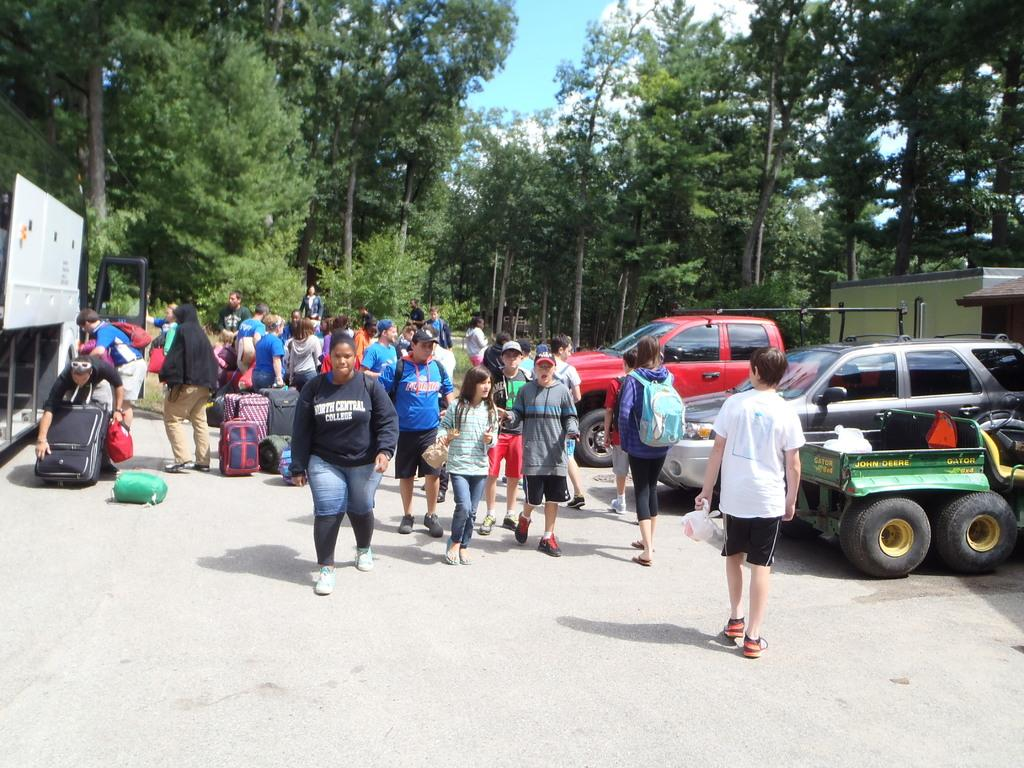How many people are in the image? There is a group of people in the image, but the exact number cannot be determined from the provided facts. What are the people carrying in the image? There are bags in the image, which might be carried by the people. What type of vehicles can be seen on the ground in the image? The vehicles on the ground in the image cannot be identified based on the provided facts. What else can be seen in the image besides the people and vehicles? There are objects in the image, but their nature cannot be determined from the provided facts. What can be seen in the background of the image? There are trees and the sky visible in the background of the image. What type of hook can be seen on the edge of the trees in the image? There is no hook visible on the edge of the trees in the image. 